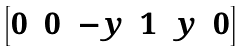<formula> <loc_0><loc_0><loc_500><loc_500>\begin{bmatrix} 0 & 0 & - y & 1 & y & 0 \end{bmatrix}</formula> 